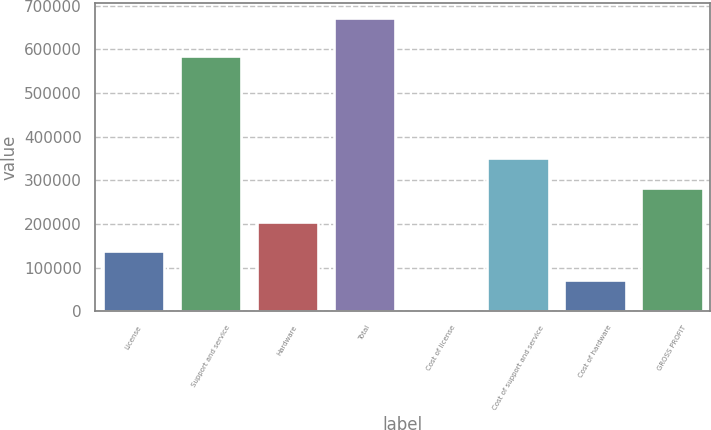Convert chart to OTSL. <chart><loc_0><loc_0><loc_500><loc_500><bar_chart><fcel>License<fcel>Support and service<fcel>Hardware<fcel>Total<fcel>Cost of license<fcel>Cost of support and service<fcel>Cost of hardware<fcel>GROSS PROFIT<nl><fcel>138242<fcel>585470<fcel>204997<fcel>672282<fcel>4732<fcel>349855<fcel>71487<fcel>283100<nl></chart> 